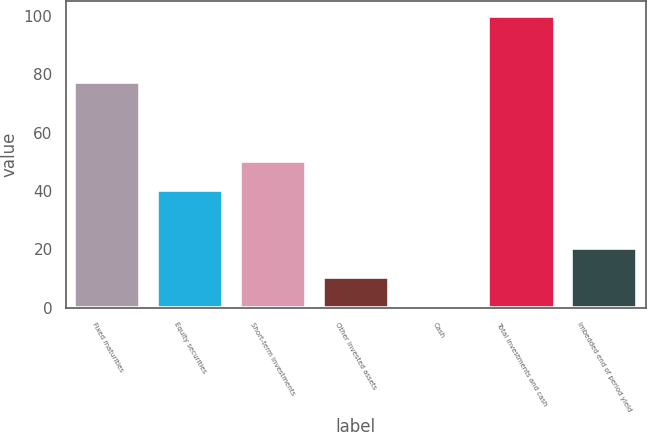Convert chart to OTSL. <chart><loc_0><loc_0><loc_500><loc_500><bar_chart><fcel>Fixed maturities<fcel>Equity securities<fcel>Short-term investments<fcel>Other invested assets<fcel>Cash<fcel>Total investments and cash<fcel>Imbedded end of period yield<nl><fcel>77.5<fcel>40.48<fcel>50.4<fcel>10.72<fcel>0.8<fcel>100<fcel>20.64<nl></chart> 